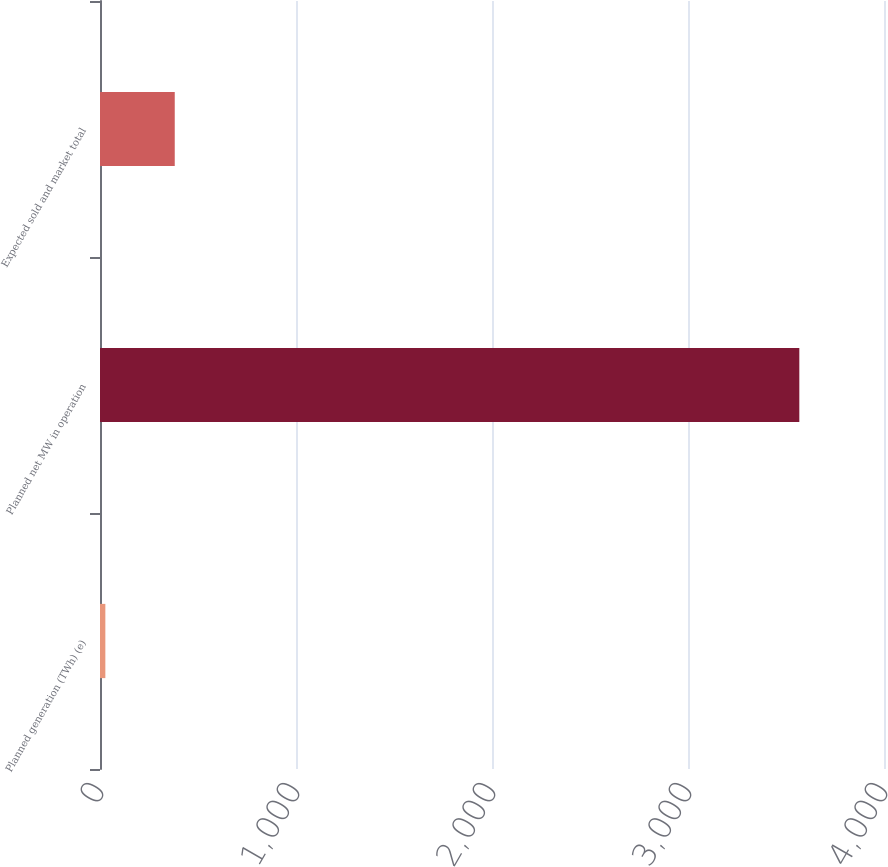<chart> <loc_0><loc_0><loc_500><loc_500><bar_chart><fcel>Planned generation (TWh) (e)<fcel>Planned net MW in operation<fcel>Expected sold and market total<nl><fcel>27.3<fcel>3568<fcel>381.37<nl></chart> 